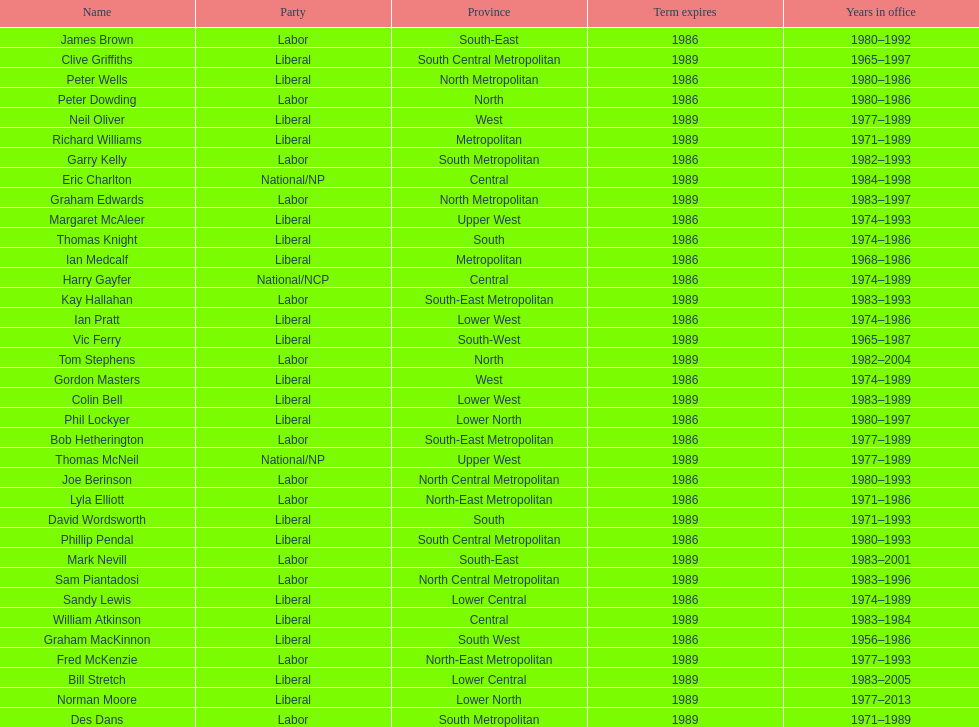What was phil lockyer's party? Liberal. 